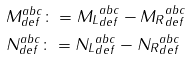<formula> <loc_0><loc_0><loc_500><loc_500>& M ^ { a b c } _ { d e f } \colon = { M _ { L } } ^ { a b c } _ { d e f } - { M _ { R } } ^ { a b c } _ { d e f } \\ & N ^ { a b c } _ { d e f } \colon = { N _ { L } } ^ { a b c } _ { d e f } - { N _ { R } } ^ { a b c } _ { d e f }</formula> 